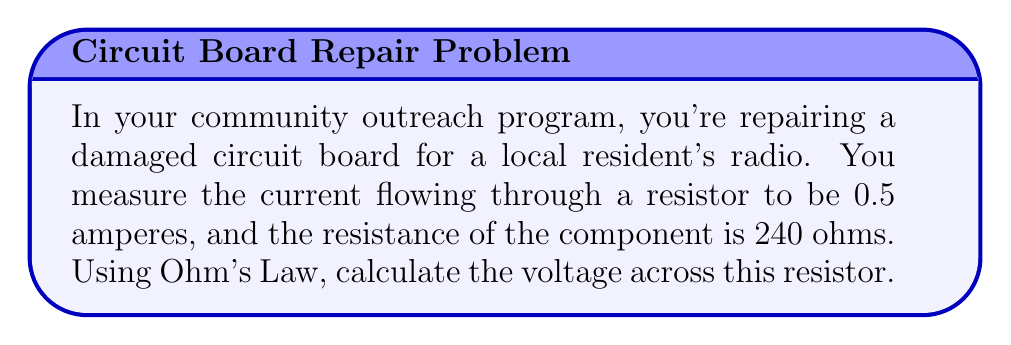What is the answer to this math problem? To solve this problem, we'll use Ohm's Law, which states that the voltage (V) across a conductor is directly proportional to the current (I) flowing through it and the resistance (R) of the conductor. The formula is:

$$V = I \times R$$

Given:
- Current (I) = 0.5 amperes
- Resistance (R) = 240 ohms

Let's substitute these values into the formula:

$$V = 0.5 \text{ A} \times 240 \text{ Ω}$$

Now, we simply multiply these values:

$$V = 120 \text{ V}$$

Therefore, the voltage across the resistor is 120 volts.
Answer: 120 V 